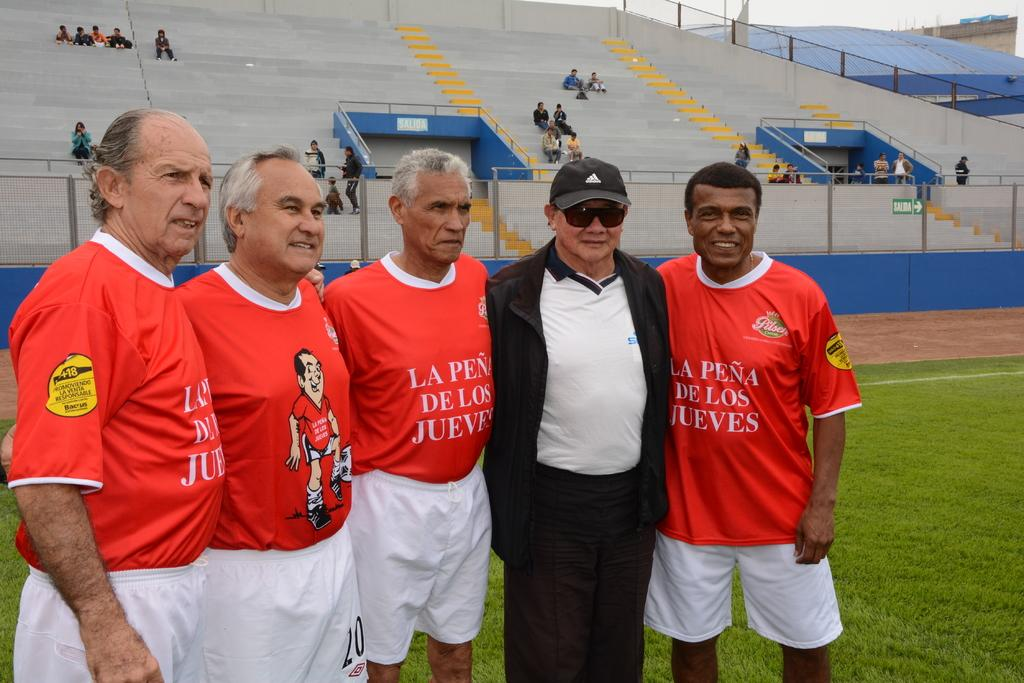How many people are present in the image? There are five people standing in the image. What type of terrain is visible in the image? There is grass visible in the image. What can be seen in the background of the image? There is a stadium, people, and a building in the background of the image. How many eggs are being held by the rabbits in the image? There are no rabbits or eggs present in the image. What type of page is visible in the image? There is no page visible in the image. 